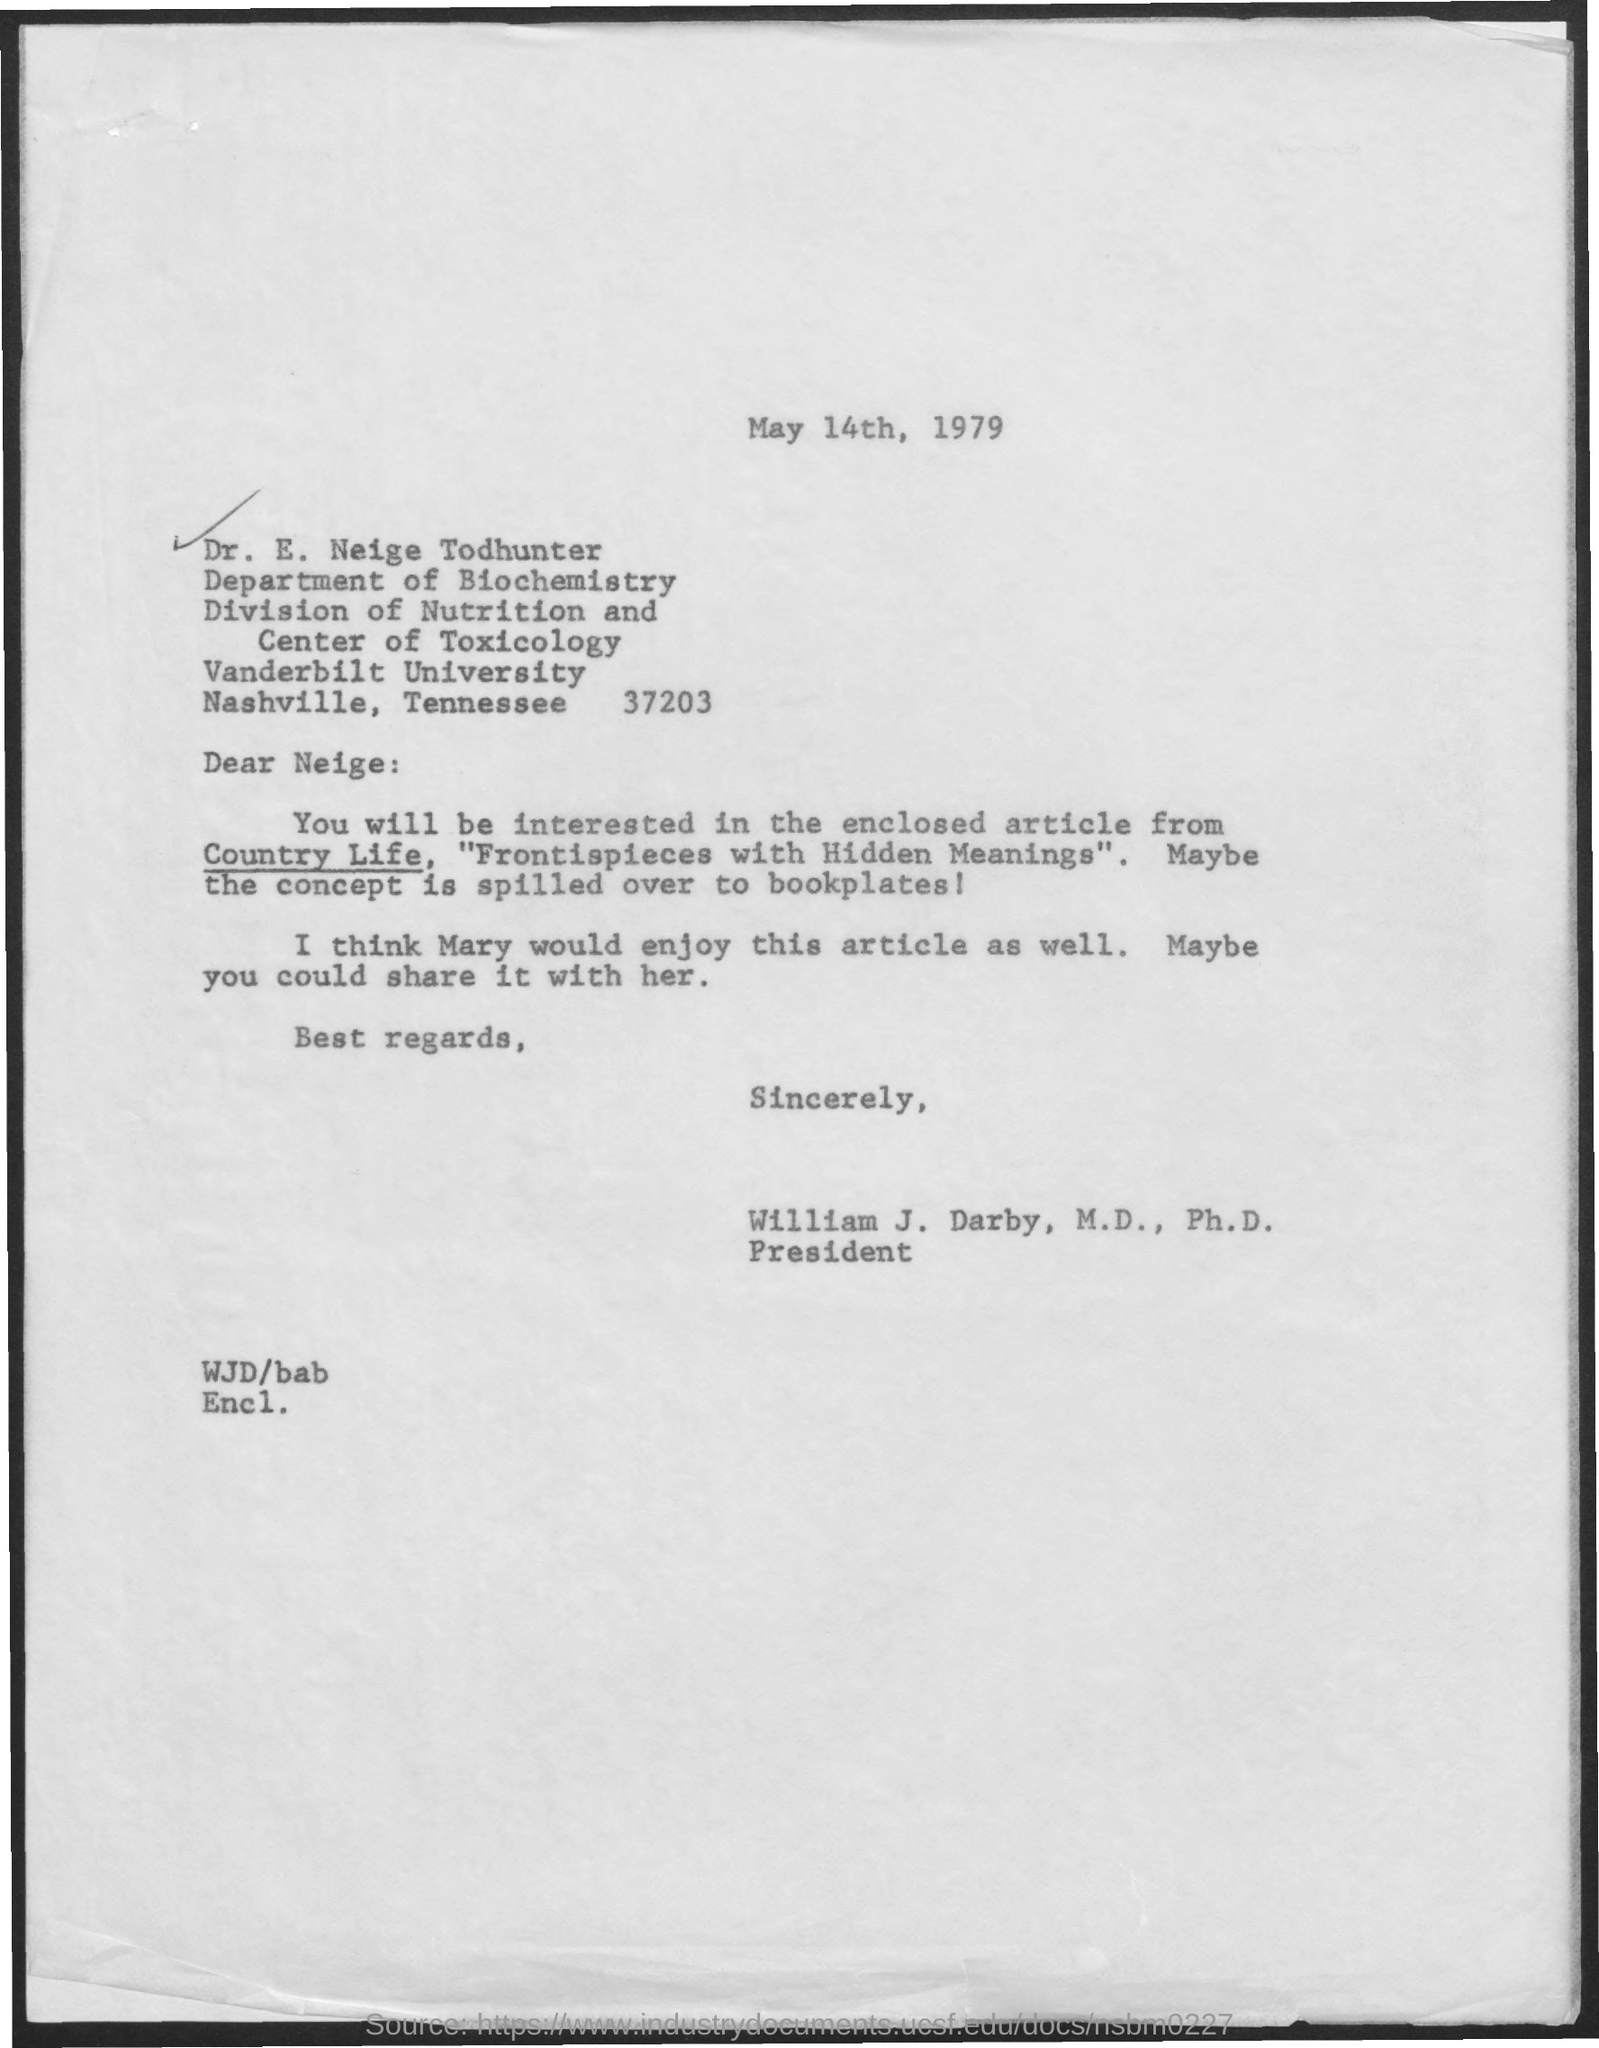Indicate a few pertinent items in this graphic. The date mentioned is May 14th, 1979. Mary would also enjoy this article. The speaker asked, 'To which department does he belong? Biochemistry, department of.' Vanderbilt University is the name of the university. The current president of the United States is William J. Darby. 